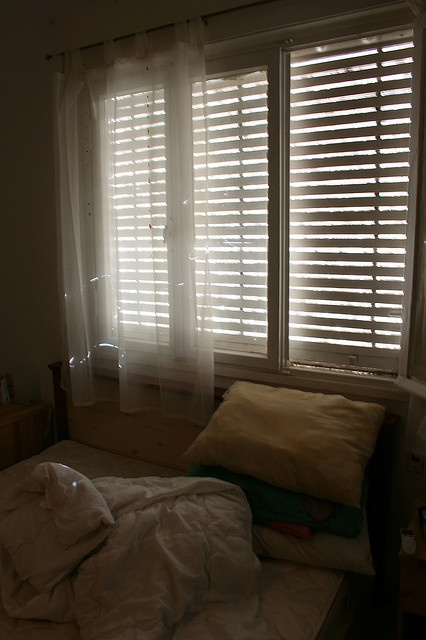Describe the objects in this image and their specific colors. I can see a bed in black and gray tones in this image. 